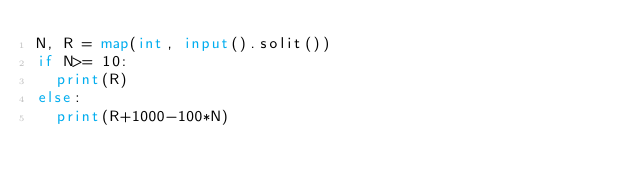Convert code to text. <code><loc_0><loc_0><loc_500><loc_500><_Python_>N, R = map(int, input().solit())
if N>= 10:
  print(R)
else:
  print(R+1000-100*N)</code> 